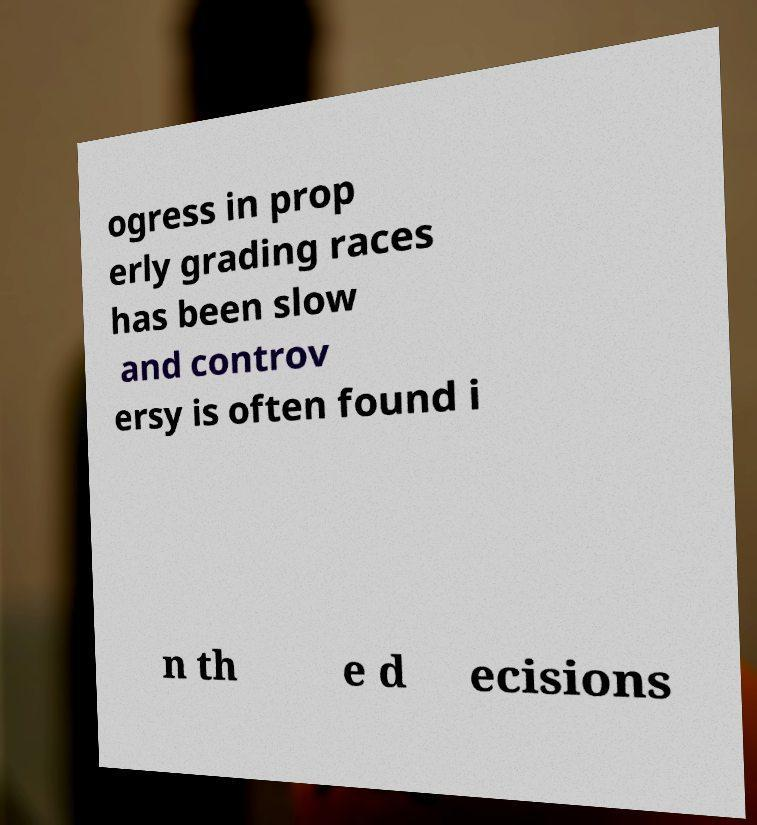What messages or text are displayed in this image? I need them in a readable, typed format. ogress in prop erly grading races has been slow and controv ersy is often found i n th e d ecisions 